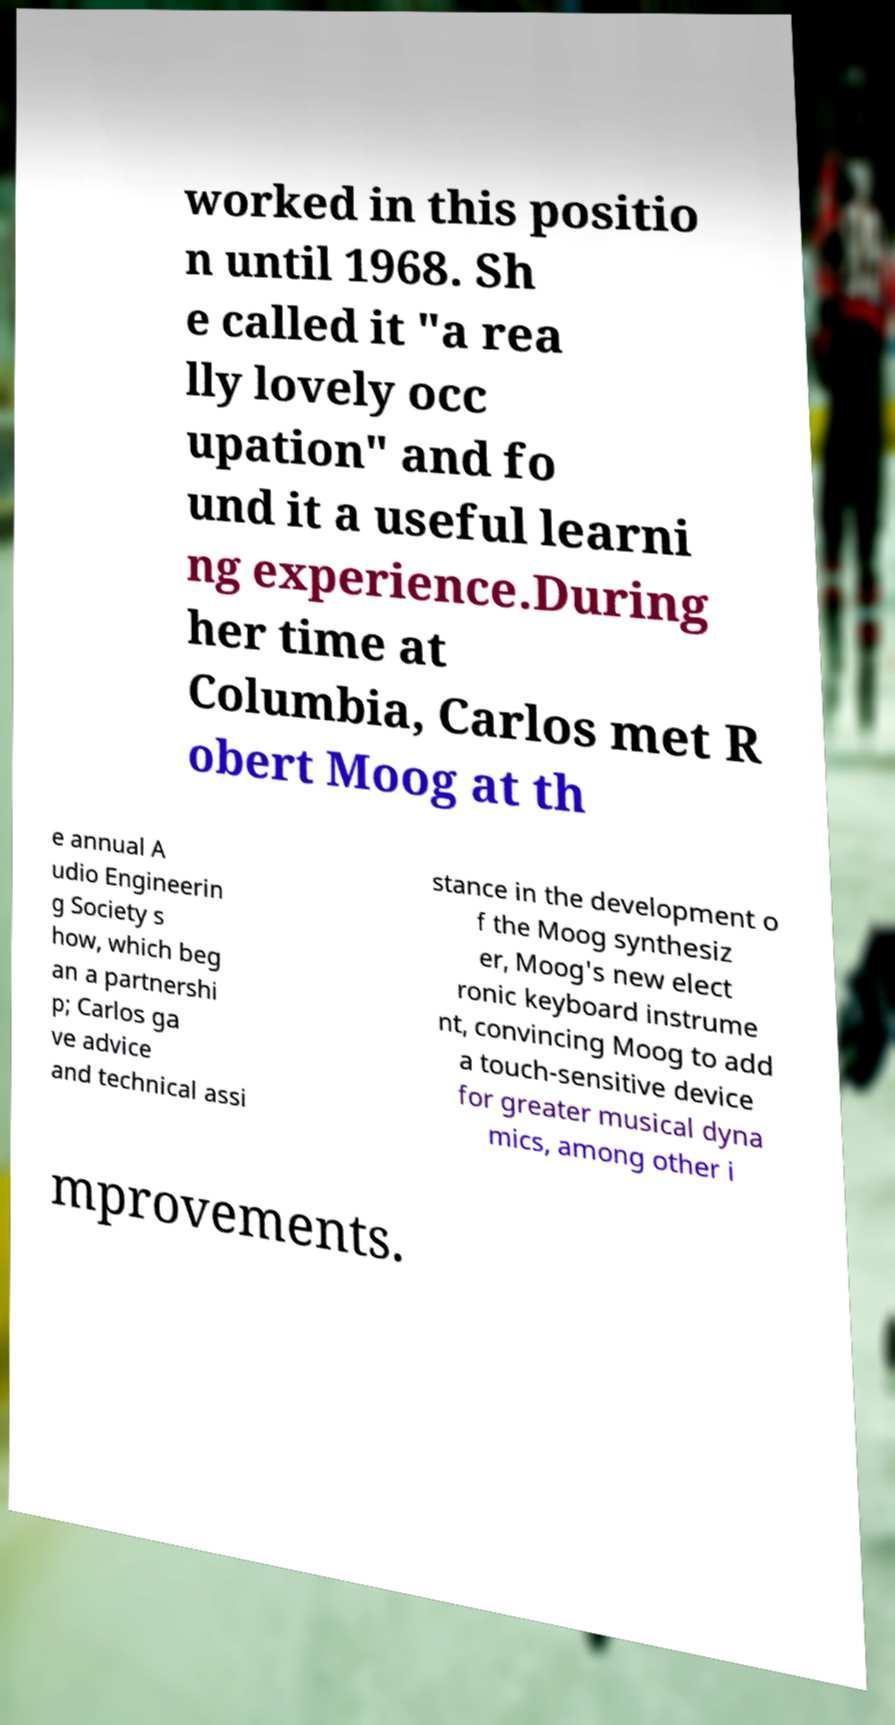Can you read and provide the text displayed in the image?This photo seems to have some interesting text. Can you extract and type it out for me? worked in this positio n until 1968. Sh e called it "a rea lly lovely occ upation" and fo und it a useful learni ng experience.During her time at Columbia, Carlos met R obert Moog at th e annual A udio Engineerin g Society s how, which beg an a partnershi p; Carlos ga ve advice and technical assi stance in the development o f the Moog synthesiz er, Moog's new elect ronic keyboard instrume nt, convincing Moog to add a touch-sensitive device for greater musical dyna mics, among other i mprovements. 